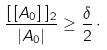Convert formula to latex. <formula><loc_0><loc_0><loc_500><loc_500>\frac { [ \, [ A _ { 0 } ] \, ] _ { 2 } } { | A _ { 0 } | } \geq \frac { \delta } { 2 } \, \cdot</formula> 